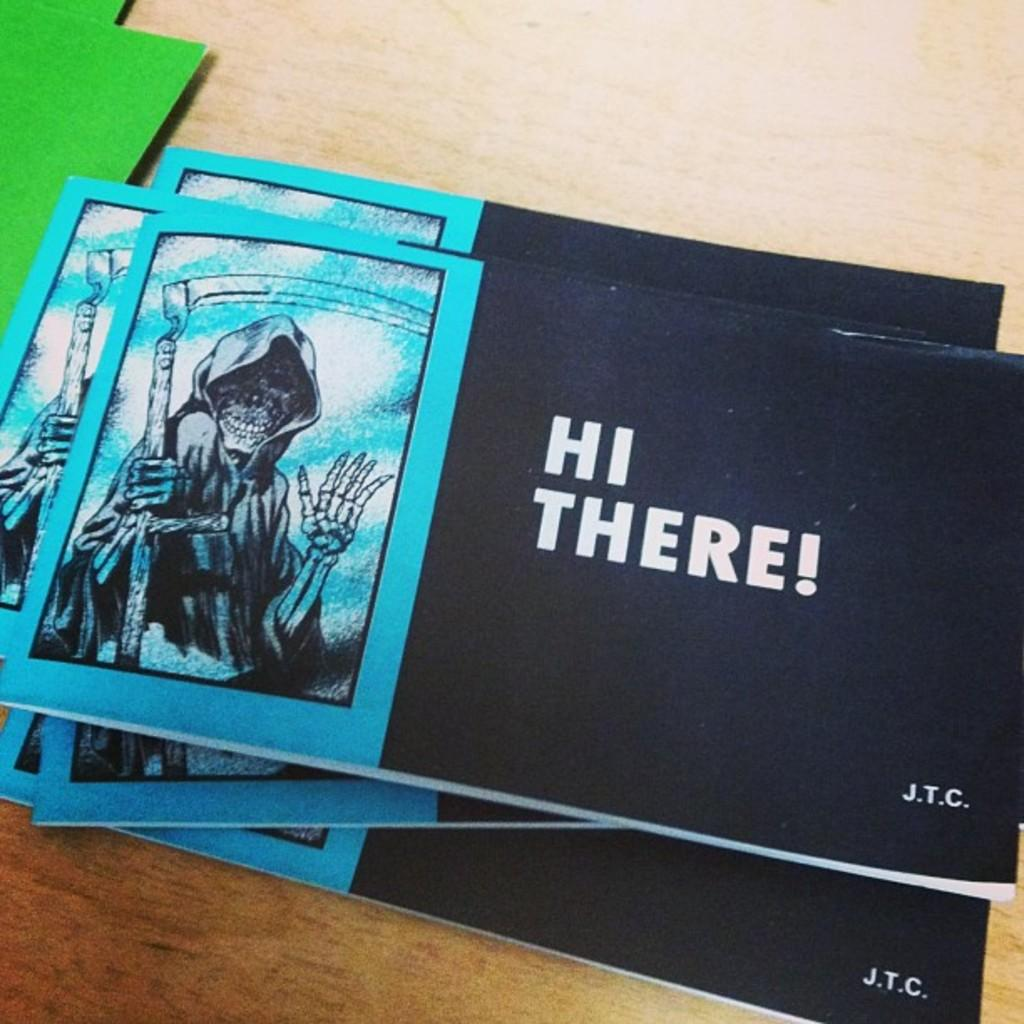Provide a one-sentence caption for the provided image. A blue and black booklet with a pic of the grim reaper on the left side and the other side is black with HI THERE! in bold white print. 